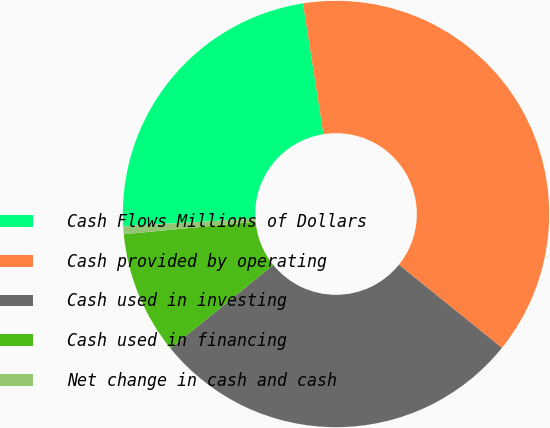Convert chart to OTSL. <chart><loc_0><loc_0><loc_500><loc_500><pie_chart><fcel>Cash Flows Millions of Dollars<fcel>Cash provided by operating<fcel>Cash used in investing<fcel>Cash used in financing<fcel>Net change in cash and cash<nl><fcel>23.44%<fcel>38.28%<fcel>28.34%<fcel>9.34%<fcel>0.6%<nl></chart> 